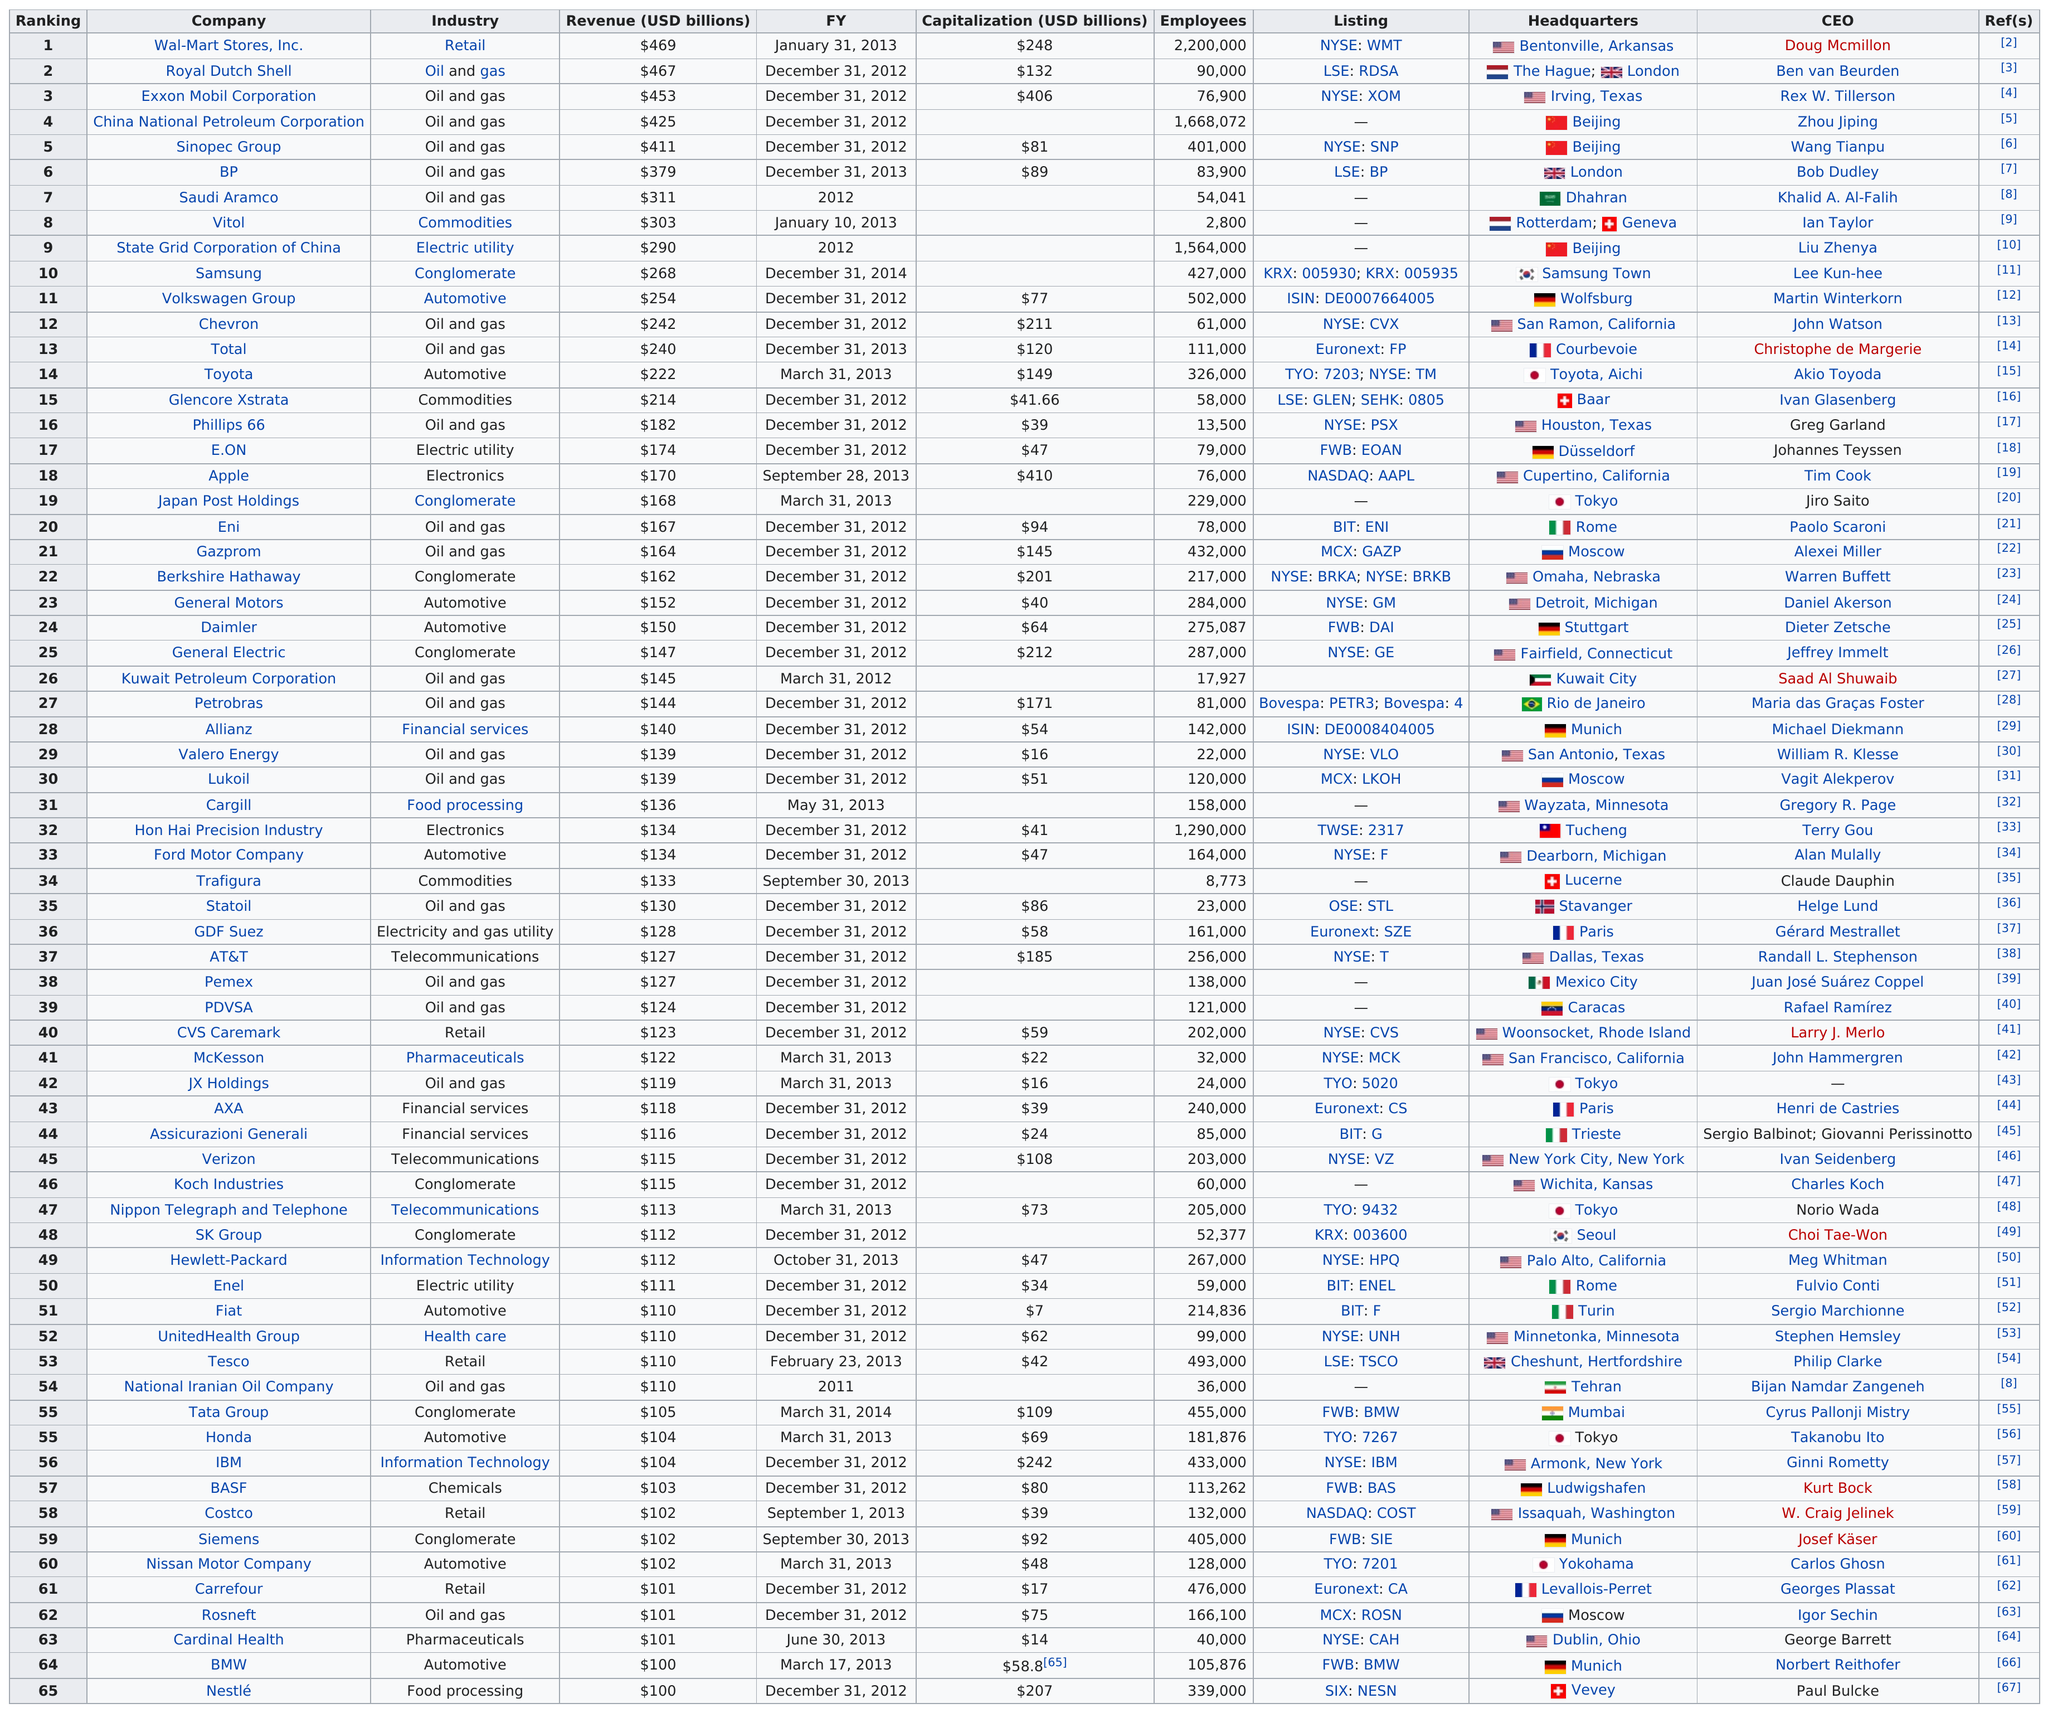Mention a couple of crucial points in this snapshot. Six oil and gas industries made it to the top 10 in the ranking of revenue list. Ford Motor Company earned the same revenue as Hon Hai Precision Industry, a Taiwanese electronics manufacturing company better known as Foxconn. Vitol has approximately 2,800 employees. Wal-Mart Stores, Inc. is ranked at the top in terms of revenue among all companies. Daimler has made more in revenue than AT&T. 